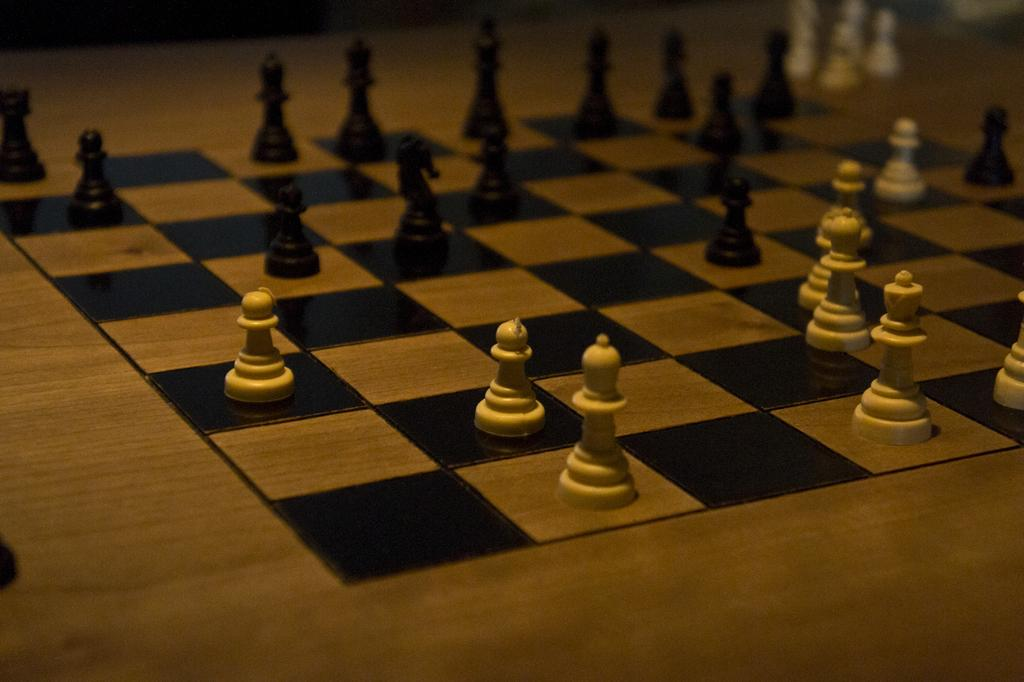What is the main subject of the image? The main subject of the image is a chess board. What colors are the chess pieces on the board? The chess pieces on the board are white and black. Can you describe the background of the image? The background of the image is blurred. What type of thought is being expressed by the chess pieces in the image? The chess pieces in the image are inanimate objects and cannot express thoughts. 